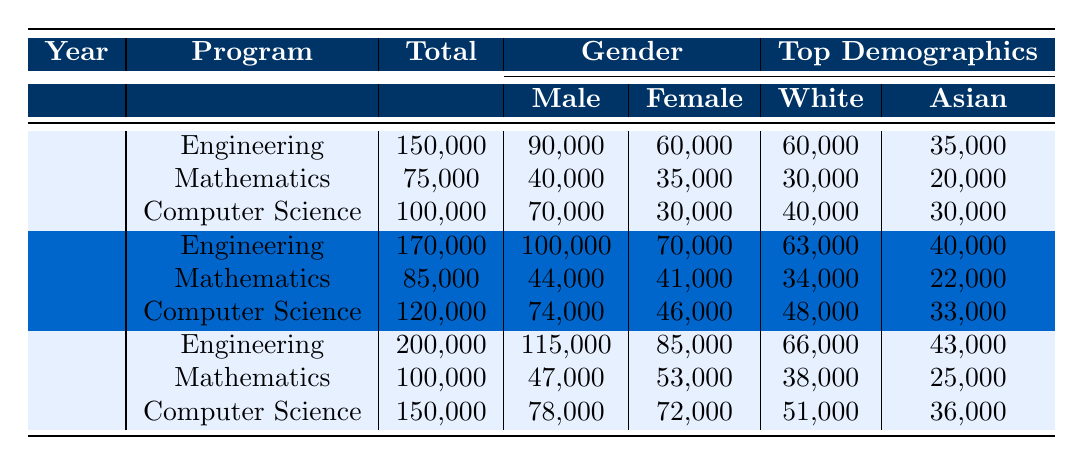What was the total enrollment in Engineering in 2020? In the table, under the year 2020 and the program Engineering, the total enrollment is listed as 170,000.
Answer: 170,000 How many more males enrolled in Computer Science than females in 2023? In 2023, the enrollment for Computer Science shows 78,000 males and 72,000 females. The difference is 78,000 - 72,000 = 6,000.
Answer: 6,000 Was the total enrollment in Mathematics higher in 2019 or in 2021? The total enrollment for Mathematics in 2019 is 80,000, and in 2021 it is 90,000. Since 90,000 is greater than 80,000, the enrollment was higher in 2021.
Answer: Yes What is the percentage of female students in Engineering in 2022? In 2022, the total enrollment in Engineering is 190,000 with 80,000 females. To find the percentage, divide 80,000 by 190,000 and multiply by 100: (80,000 / 190,000) * 100 ≈ 42.1%.
Answer: Approximately 42.1% What was the change in total enrollment for Computer Science from 2018 to 2023? The total enrollment for Computer Science in 2018 was 100,000 and in 2023 it is 150,000. The change is calculated as 150,000 - 100,000 = 50,000.
Answer: 50,000 How many more Asian students enrolled in Engineering in 2021 compared to 2018? In 2021, the number of Asian students in Engineering was 41,000, and in 2018 it was 35,000. The difference is 41,000 - 35,000 = 6,000.
Answer: 6,000 What is the total male enrollment across all programs for the year 2019? The male enrollments for each program in 2019 are 95,000 (Engineering), 42,000 (Mathematics), and 72,000 (Computer Science). Adding these values together gives 95,000 + 42,000 + 72,000 = 209,000.
Answer: 209,000 In which year did the Engineering program reach its highest enrollment? By examining the total enrollment numbers for Engineering across the years, the highest enrollment is in 2023 with 200,000 students.
Answer: 2023 What was the percentage of total enrollment for females in Mathematics in 2020? The total enrollment in Mathematics in 2020 was 85,000 with 41,000 females. The percentage is calculated as (41,000 / 85,000) * 100 ≈ 48.2%.
Answer: Approximately 48.2% Which demographic group had the highest enrollment in Computer Science in 2022? In 2022, the highest demographic group in Computer Science was White students, with an enrollment of 50,000, which is greater than all other demographic numbers listed.
Answer: White students 